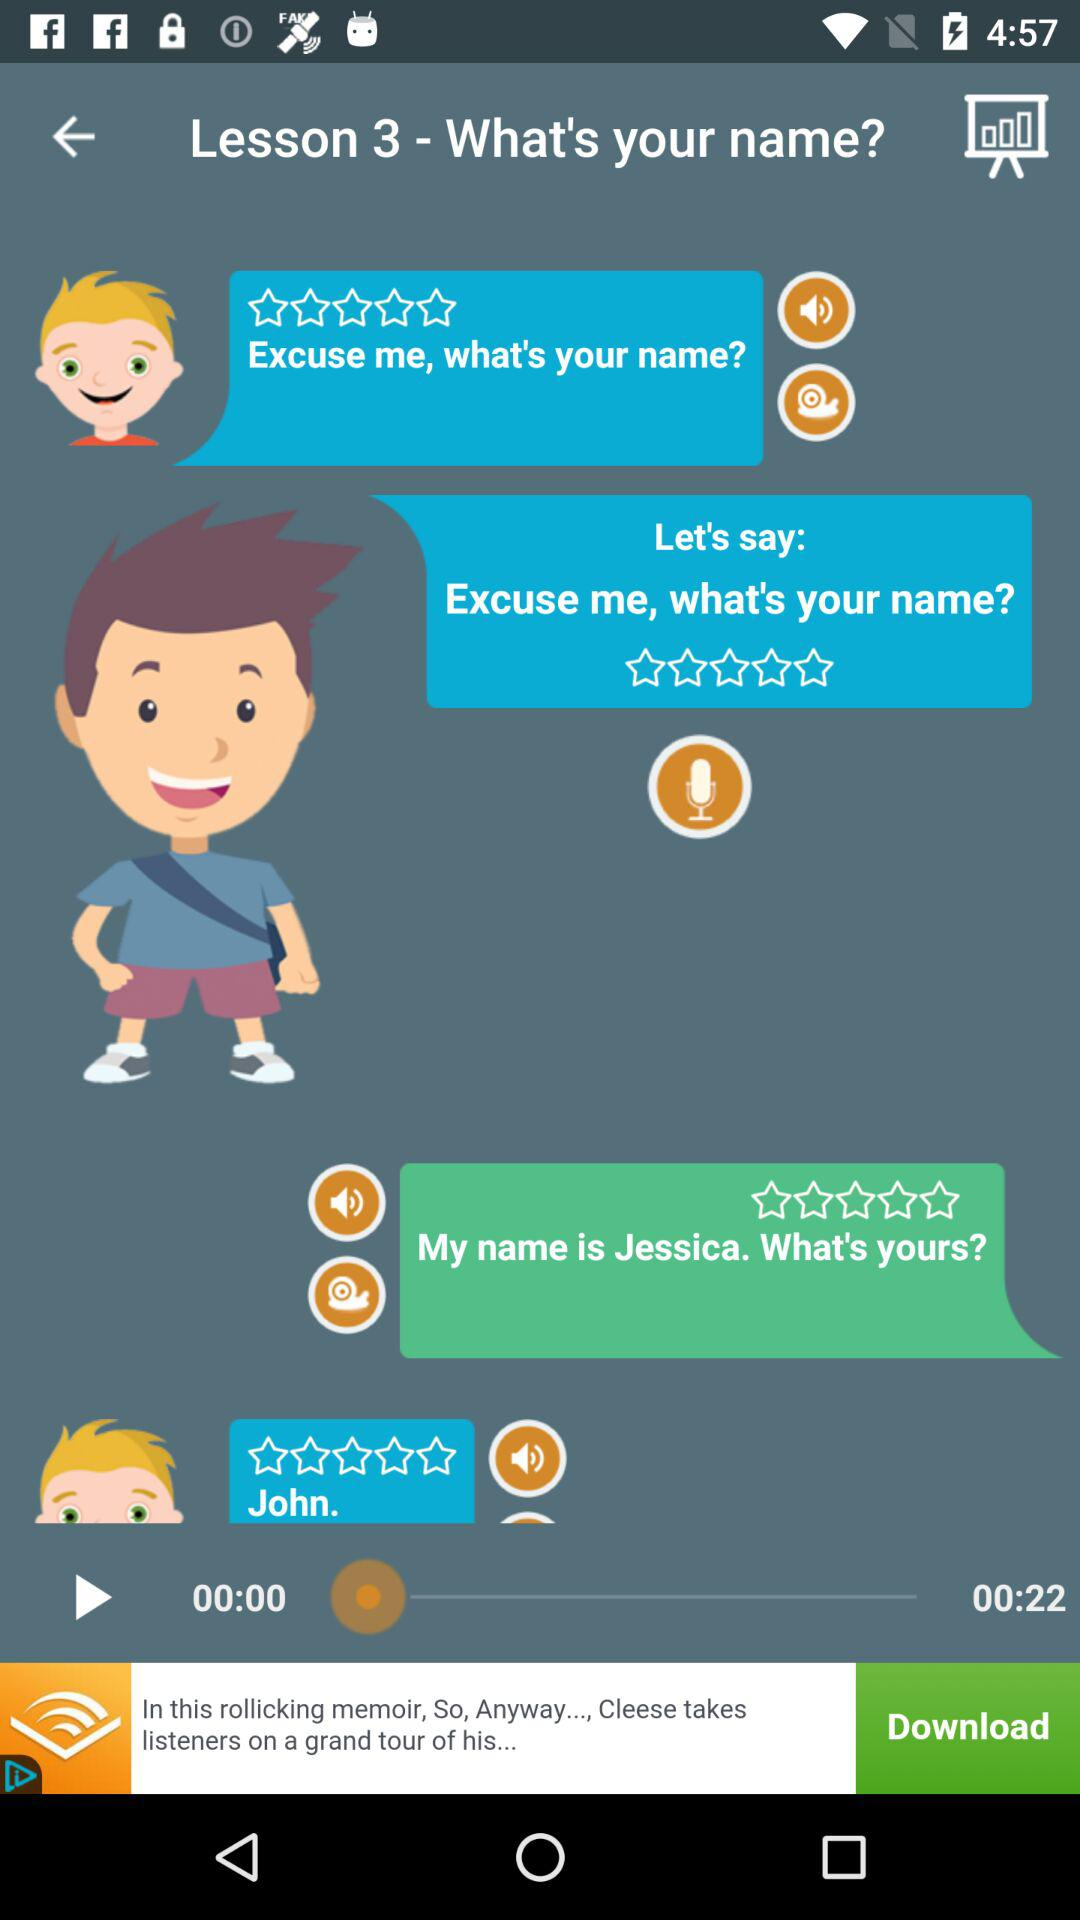What is the duration of the video? The duration is 22 seconds. 